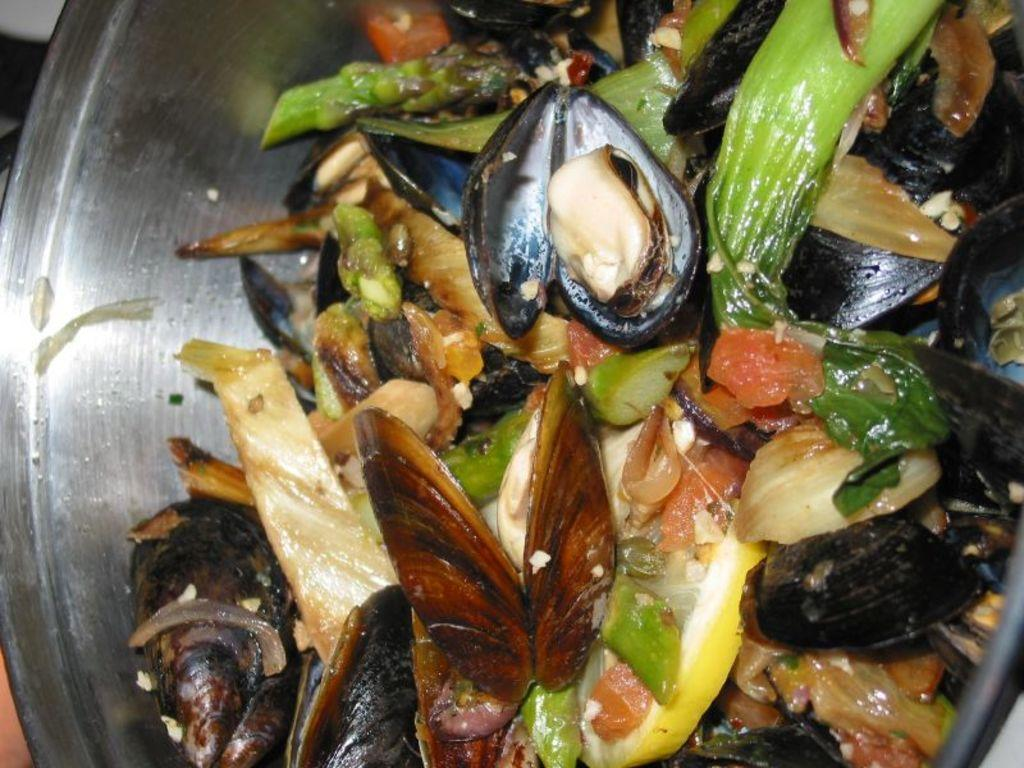What is in the bowl that is visible in the image? There are food items in a bowl in the image. Can you describe the food items in the bowl? Unfortunately, the specific food items cannot be identified from the given facts. Are there any utensils or other items visible with the bowl? The provided facts do not mention any utensils or additional items. What type of trousers are the police officers wearing in the image? There are no police officers or trousers present in the image; it only features a bowl with food items. 